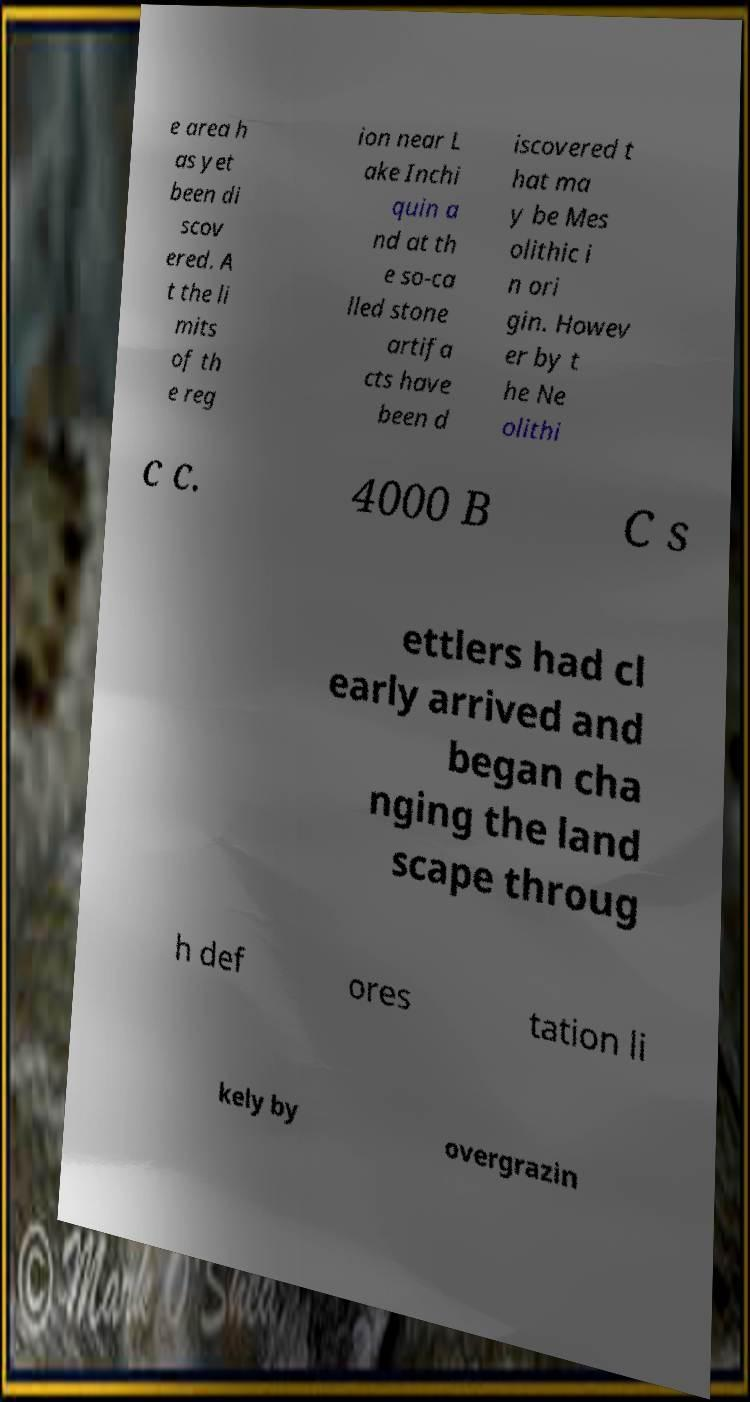Can you read and provide the text displayed in the image?This photo seems to have some interesting text. Can you extract and type it out for me? e area h as yet been di scov ered. A t the li mits of th e reg ion near L ake Inchi quin a nd at th e so-ca lled stone artifa cts have been d iscovered t hat ma y be Mes olithic i n ori gin. Howev er by t he Ne olithi c c. 4000 B C s ettlers had cl early arrived and began cha nging the land scape throug h def ores tation li kely by overgrazin 